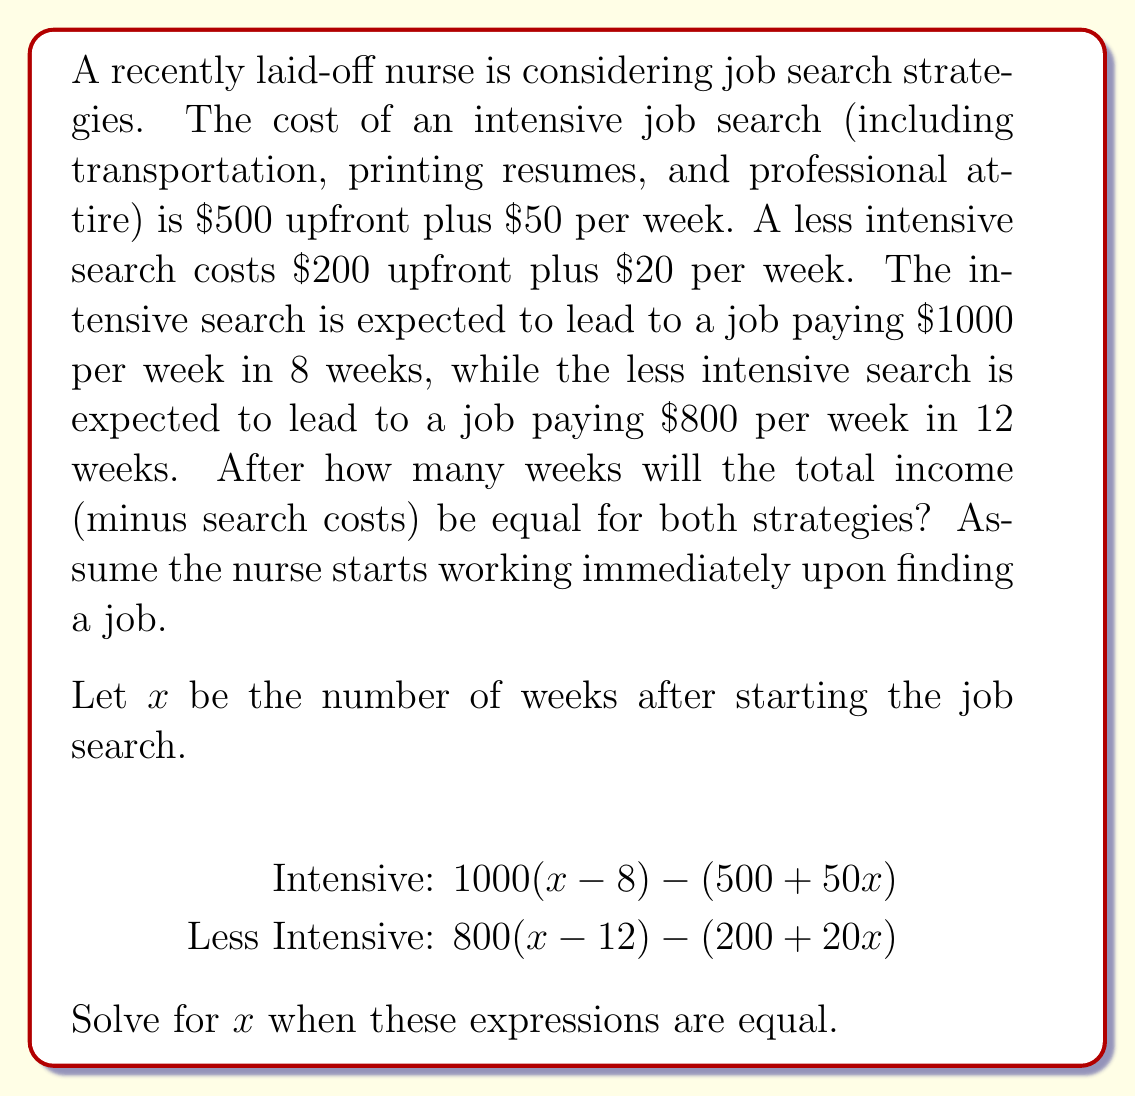Help me with this question. Let's approach this step-by-step:

1) Set up the equation:
   $1000(x-8) - (500 + 50x) = 800(x-12) - (200 + 20x)$

2) Expand the brackets:
   $1000x - 8000 - 500 - 50x = 800x - 9600 - 200 - 20x$

3) Combine like terms:
   $950x - 8500 = 780x - 9800$

4) Subtract 780x from both sides:
   $170x - 8500 = -9800$

5) Add 8500 to both sides:
   $170x = -1300$

6) Divide both sides by 170:
   $x = -\frac{1300}{170} = -\frac{130}{17} \approx -7.65$

7) Since negative time doesn't make sense in this context, we need to interpret this result. The negative value indicates that the intensive strategy becomes more profitable before the job is even found.

8) To find when the intensive strategy actually breaks even, we need to solve:
   $1000(x-8) - (500 + 50x) = 0$

9) Simplify:
   $1000x - 8000 - 500 - 50x = 0$
   $950x - 8500 = 0$
   $950x = 8500$
   $x = \frac{8500}{950} = 8.95$

This means the intensive strategy breaks even after about 9 weeks, which is just after the expected job acquisition time.
Answer: The intensive job search strategy becomes more profitable than the less intensive strategy immediately. It breaks even (income equals costs) after approximately 9 weeks. 